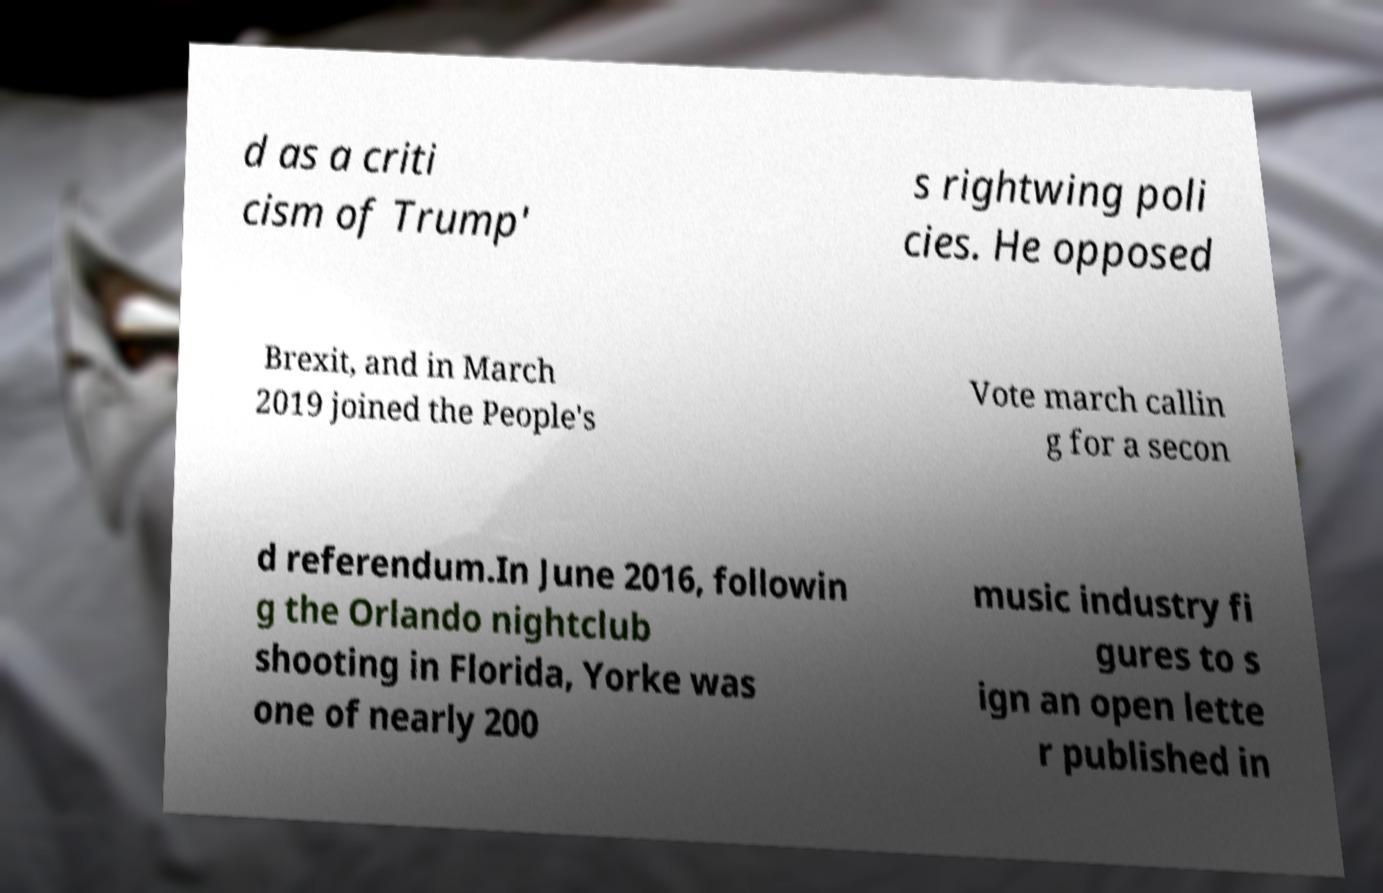Can you read and provide the text displayed in the image?This photo seems to have some interesting text. Can you extract and type it out for me? d as a criti cism of Trump' s rightwing poli cies. He opposed Brexit, and in March 2019 joined the People's Vote march callin g for a secon d referendum.In June 2016, followin g the Orlando nightclub shooting in Florida, Yorke was one of nearly 200 music industry fi gures to s ign an open lette r published in 